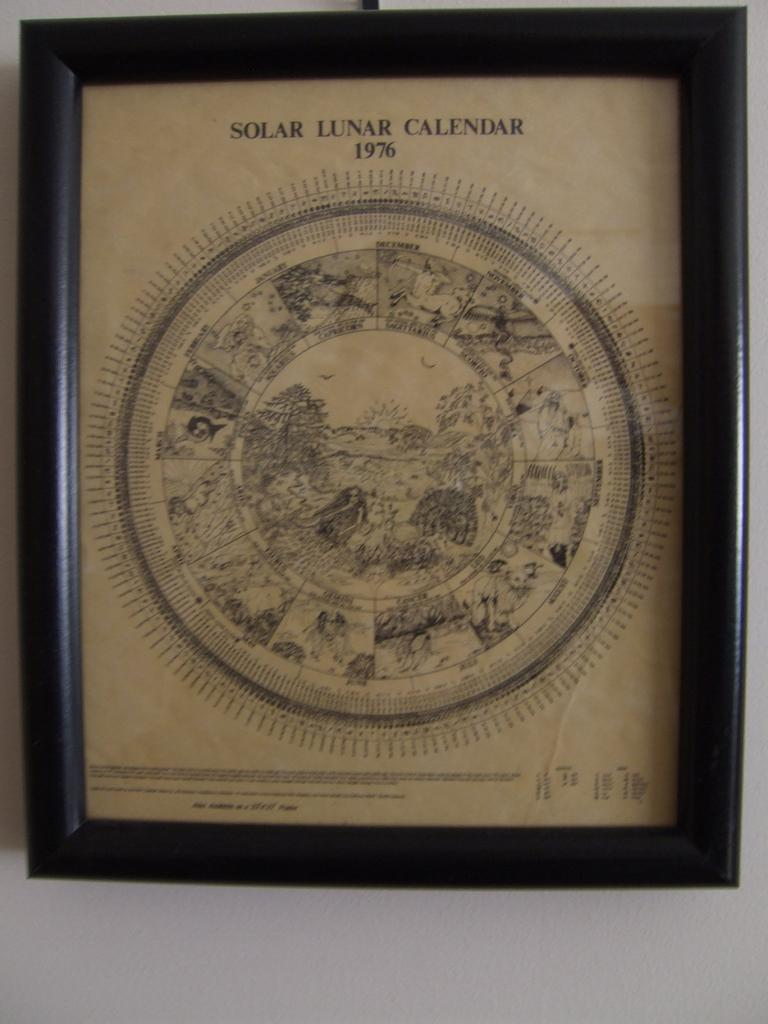<image>
Provide a brief description of the given image. A black framed Solar Lunar Calendar from 1976. 